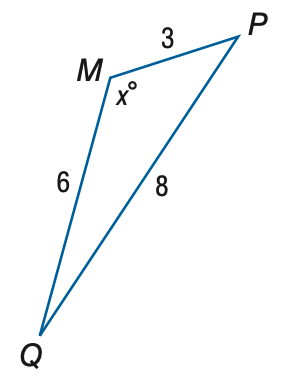Answer the mathemtical geometry problem and directly provide the correct option letter.
Question: Find x. Round to the nearest degree.
Choices: A: 102 B: 112 C: 122 D: 132 C 